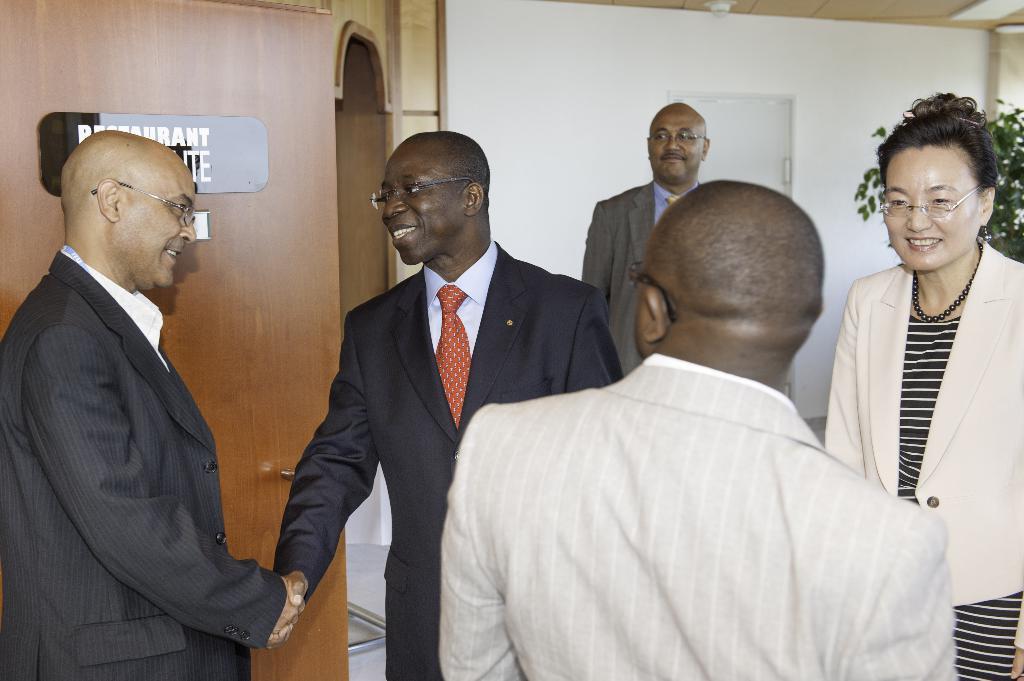How would you summarize this image in a sentence or two? In this picture I can see people standing with smiles. I can see the door on the left side. I can see light arrangements on the floor. I can see name plate board on the left side. I can see the plant on the right side. 